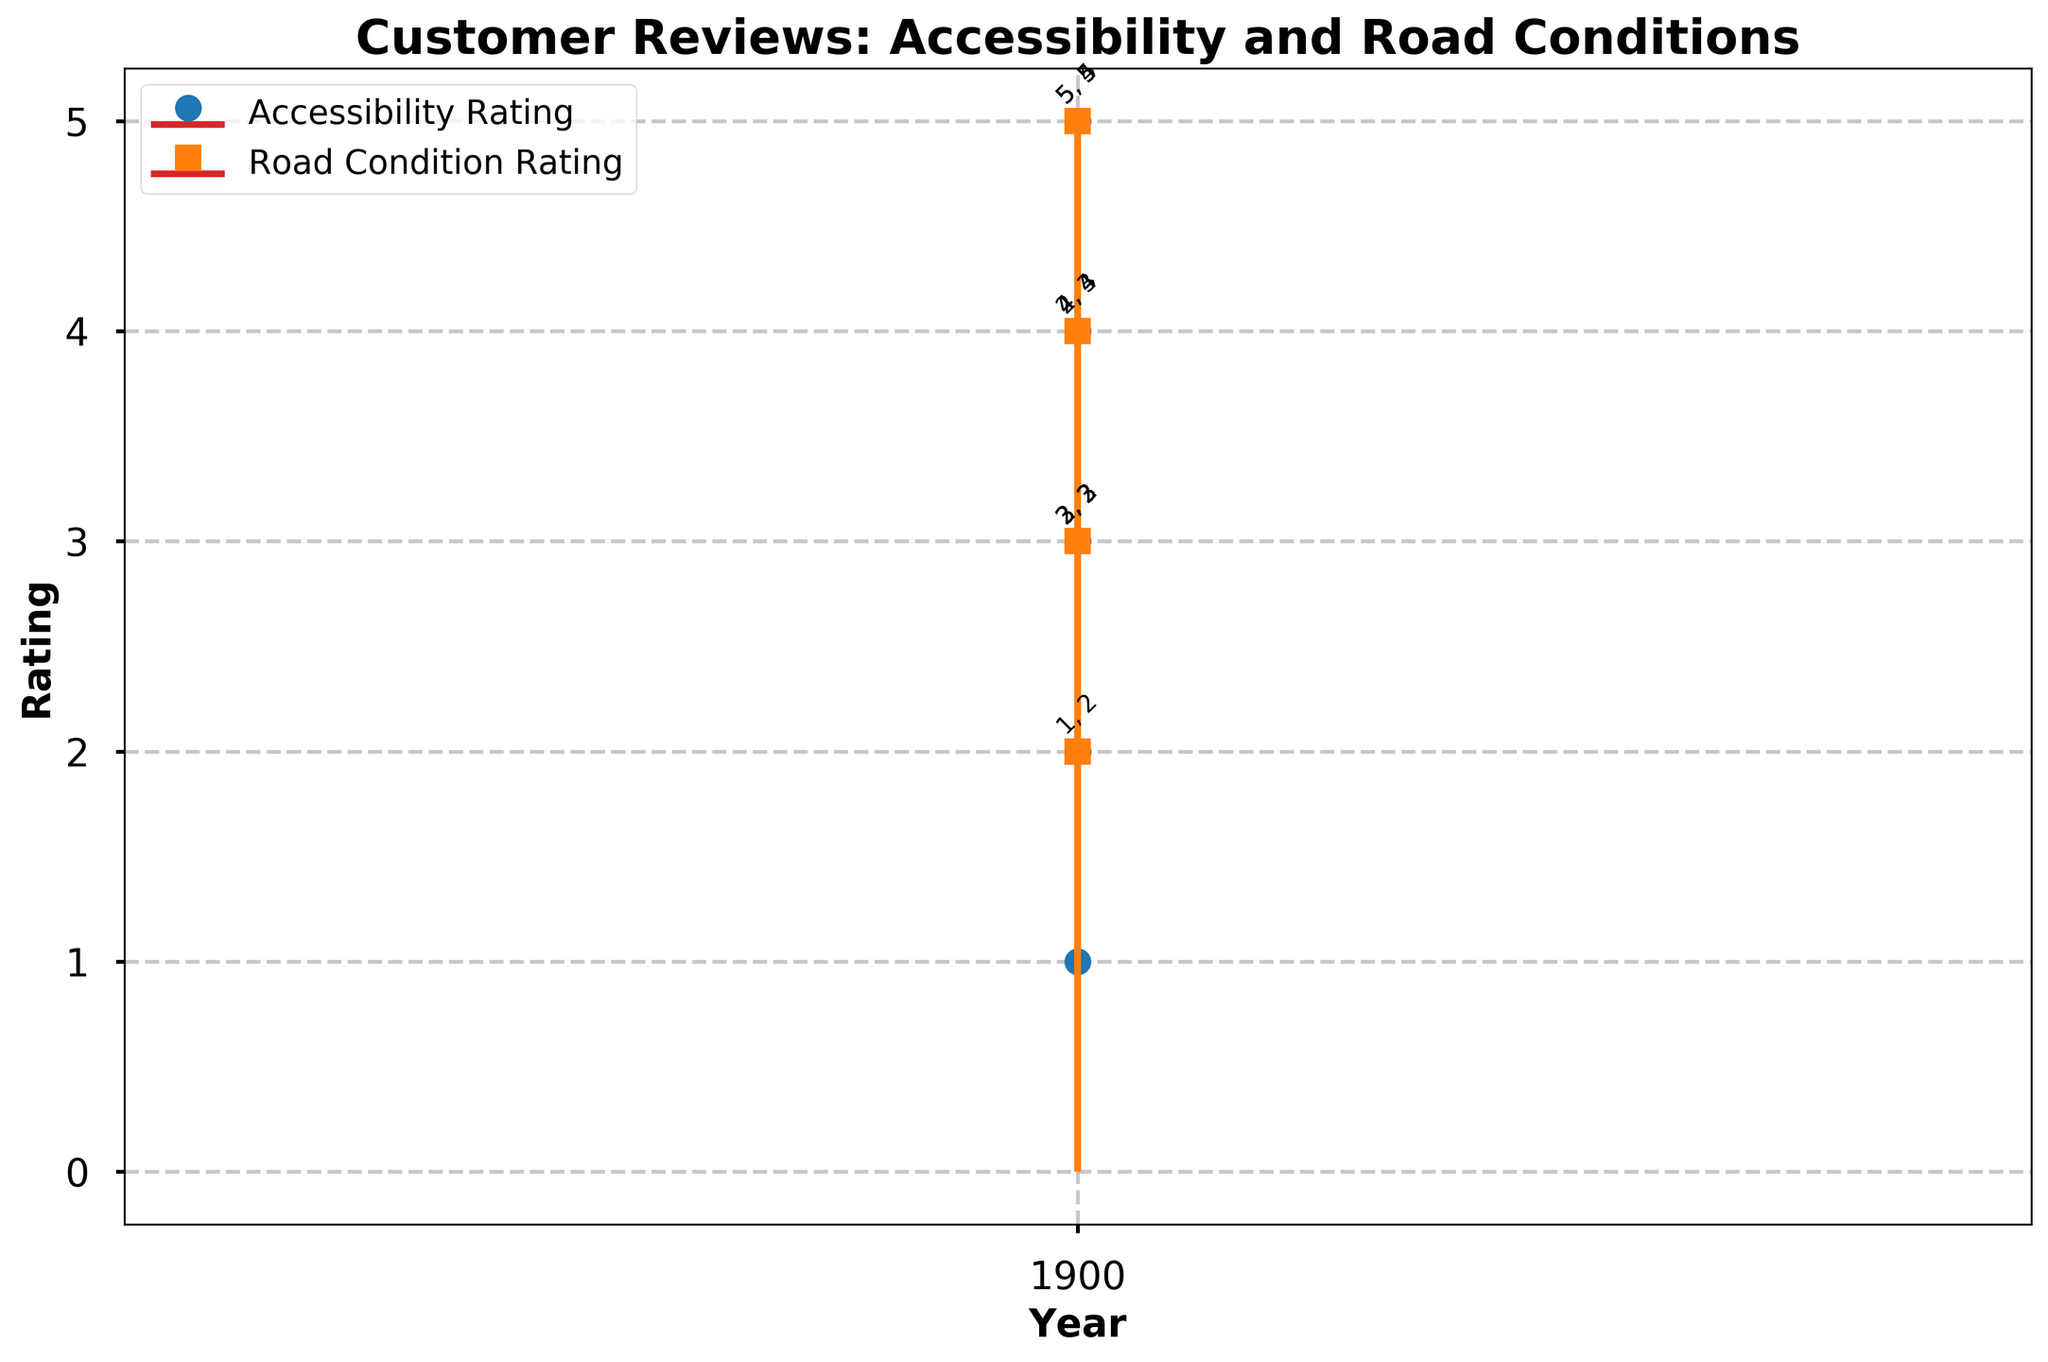What's the title of the figure? The title can be found at the top of the figure. It reads "Customer Reviews: Accessibility and Road Conditions".
Answer: Customer Reviews: Accessibility and Road Conditions How many years of data are presented in the figure? By looking at the x-axis, you can count the unique years presented. There are five unique years shown: 2018, 2019, 2020, 2021, and 2022.
Answer: 5 Which year had the highest accessibility rating? By examining the stem plot for the accessibility ratings, the highest rating is a 5. This occurs in 2018, 2021, and 2022. Hence, these three years have the highest accessibility rating.
Answer: 2018, 2021, 2022 Were there any years when the road condition rating was consistently higher than the accessibility rating? By comparing the stems of both ratings for each year, we see that in 2018 and 2020 the road condition rating is sometimes higher, such as in the February and March data points for 2018 and March for 2020. However, this is not consistent throughout the entire year.
Answer: No What was the average accessibility rating in 2020? In 2020, the accessibility ratings were 1, 2, and 4. To find the average: (1 + 2 + 4) / 3 = 7 / 3 ≈ 2.33
Answer: 2.33 How did the road condition rating tend to change over the years? Most years show fluctuations, but generally, the road condition rating tends to be around 3 or 4. For instance, in 2019, the rating fluctuates from 3 to 4, and in 2020 it starts lower and then increases.
Answer: Fluctuating with a tendency around 3 or 4 During which year did the accessibility rating show the most significant improvement? By checking the accessibility rating stems year by year, 2019 to 2020 shows a drop and then a peak again. The most notable improvement is arguably from 2020 to 2021 where it rises significantly from 1 and 2 to 5 and 4.
Answer: 2021 Is there any year where both the accessibility and road condition ratings are the same? By comparing both ratings for each year, we notice that in 2019, both ratings are 3 and 4 during some points in the year, reflecting they match at those points.
Answer: 2019 for some points What was the lowest road condition rating and when did it occur? The lowest road condition rating lies at 2. By following the stem markers for road conditions, we see this occurred in 2018 and 2020.
Answer: 2018 and 2020 How many times did the accessibility rating coincide with the maximum rating of 5? From the stems marked for accessibility ratings, the maximum rating of 5 is seen three times: in 2018, 2021, and 2022.
Answer: 3 